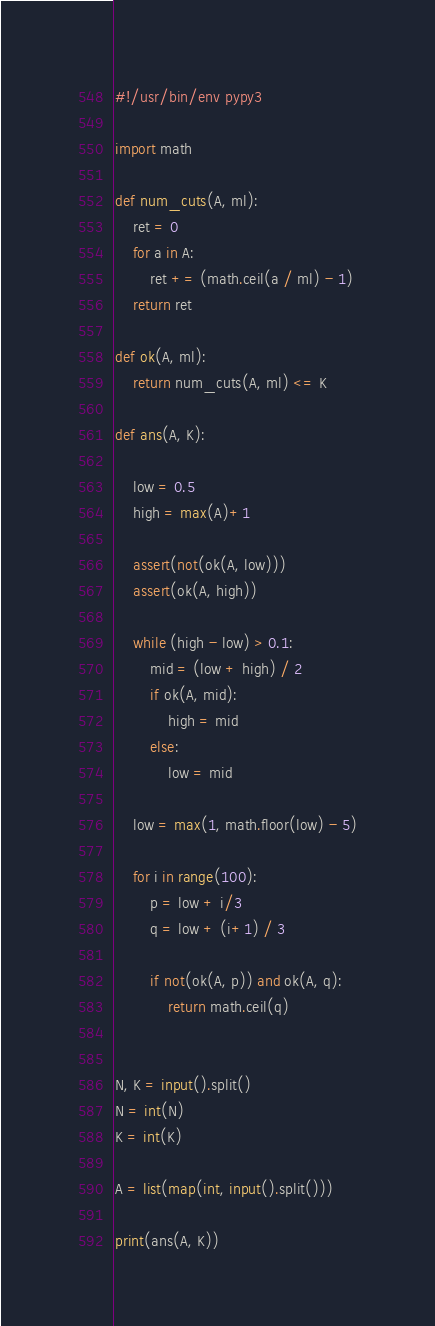<code> <loc_0><loc_0><loc_500><loc_500><_Python_>#!/usr/bin/env pypy3

import math

def num_cuts(A, ml):
	ret = 0
	for a in A:
		ret += (math.ceil(a / ml) - 1)
	return ret

def ok(A, ml):
	return num_cuts(A, ml) <= K

def ans(A, K):

	low = 0.5
	high = max(A)+1

	assert(not(ok(A, low)))
	assert(ok(A, high))

	while (high - low) > 0.1:
		mid = (low + high) / 2
		if ok(A, mid):
			high = mid
		else:
			low = mid

	low = max(1, math.floor(low) - 5)

	for i in range(100):
		p = low + i/3
		q = low + (i+1) / 3

		if not(ok(A, p)) and ok(A, q):
			return math.ceil(q)


N, K = input().split()
N = int(N)
K = int(K)

A = list(map(int, input().split()))

print(ans(A, K))</code> 